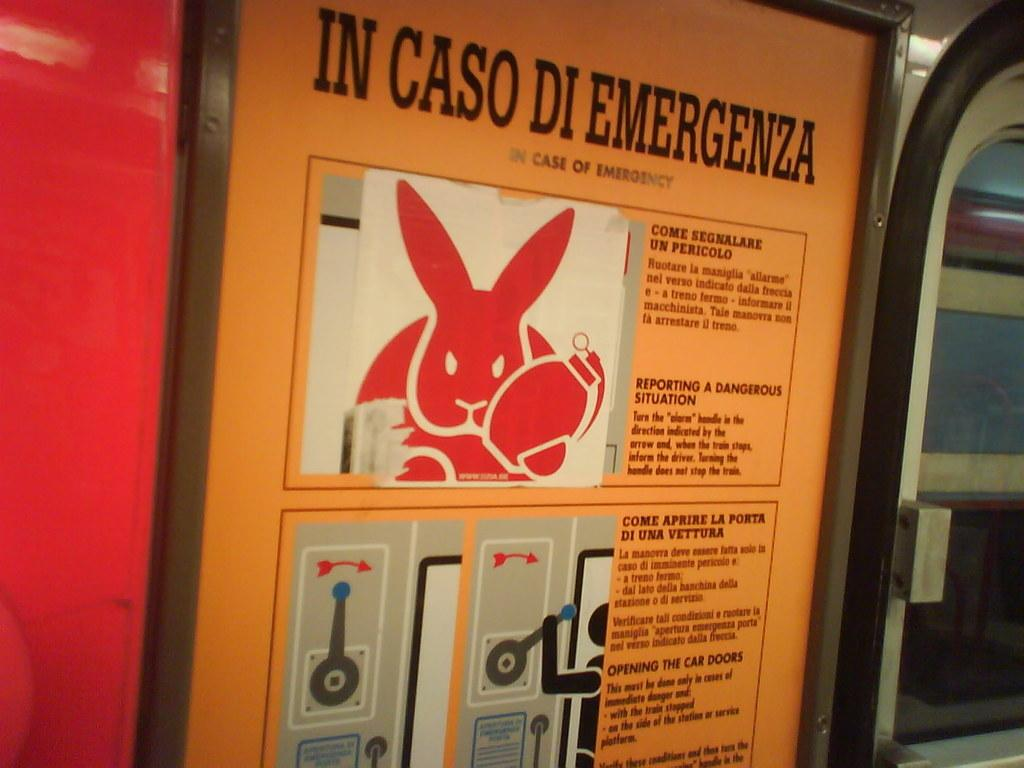What can be found on the board in the image? There are instructions on a board in the image. What type of window is visible on the right side of the image? There is a glass window on the right side of the image. Where is the sheet of paper with the police report located in the image? There is no sheet of paper with a police report present in the image. What type of wilderness can be seen through the glass window in the image? There is no wilderness visible through the glass window in the image; it is a window and not a view of any wilderness area. 